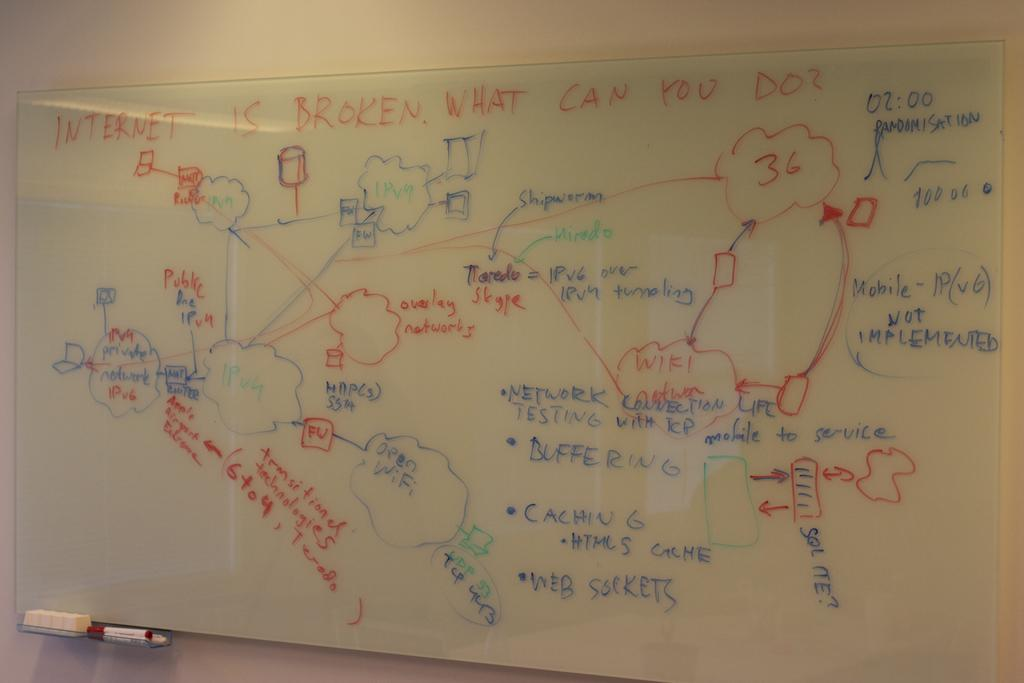<image>
Describe the image concisely. A white board displays the message Internet is broken what can you do. 